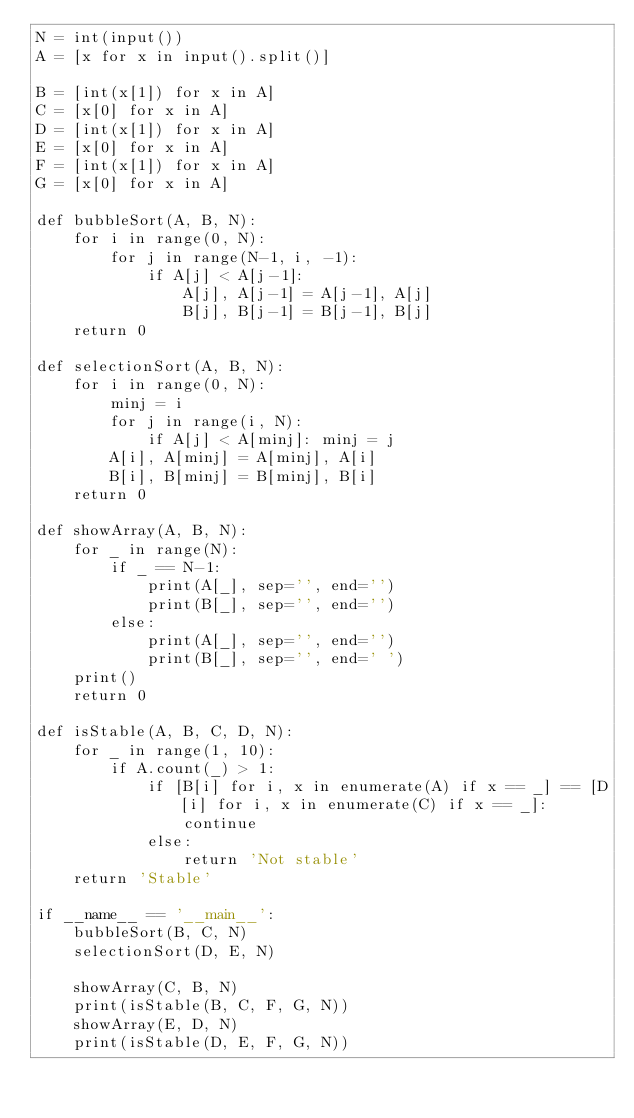<code> <loc_0><loc_0><loc_500><loc_500><_Python_>N = int(input())
A = [x for x in input().split()]

B = [int(x[1]) for x in A]
C = [x[0] for x in A]
D = [int(x[1]) for x in A]
E = [x[0] for x in A]
F = [int(x[1]) for x in A]
G = [x[0] for x in A]

def bubbleSort(A, B, N):
    for i in range(0, N):
        for j in range(N-1, i, -1):
            if A[j] < A[j-1]:
                A[j], A[j-1] = A[j-1], A[j]
                B[j], B[j-1] = B[j-1], B[j]
    return 0

def selectionSort(A, B, N):
    for i in range(0, N):
        minj = i
        for j in range(i, N):
            if A[j] < A[minj]: minj = j
        A[i], A[minj] = A[minj], A[i]
        B[i], B[minj] = B[minj], B[i]
    return 0

def showArray(A, B, N):
    for _ in range(N):
        if _ == N-1:
            print(A[_], sep='', end='')
            print(B[_], sep='', end='')
        else:
            print(A[_], sep='', end='')
            print(B[_], sep='', end=' ')
    print()
    return 0

def isStable(A, B, C, D, N):
    for _ in range(1, 10):
        if A.count(_) > 1:
            if [B[i] for i, x in enumerate(A) if x == _] == [D[i] for i, x in enumerate(C) if x == _]:
                continue
            else:
                return 'Not stable'
    return 'Stable'

if __name__ == '__main__':
    bubbleSort(B, C, N)
    selectionSort(D, E, N)
    
    showArray(C, B, N)
    print(isStable(B, C, F, G, N))
    showArray(E, D, N)
    print(isStable(D, E, F, G, N))
</code> 